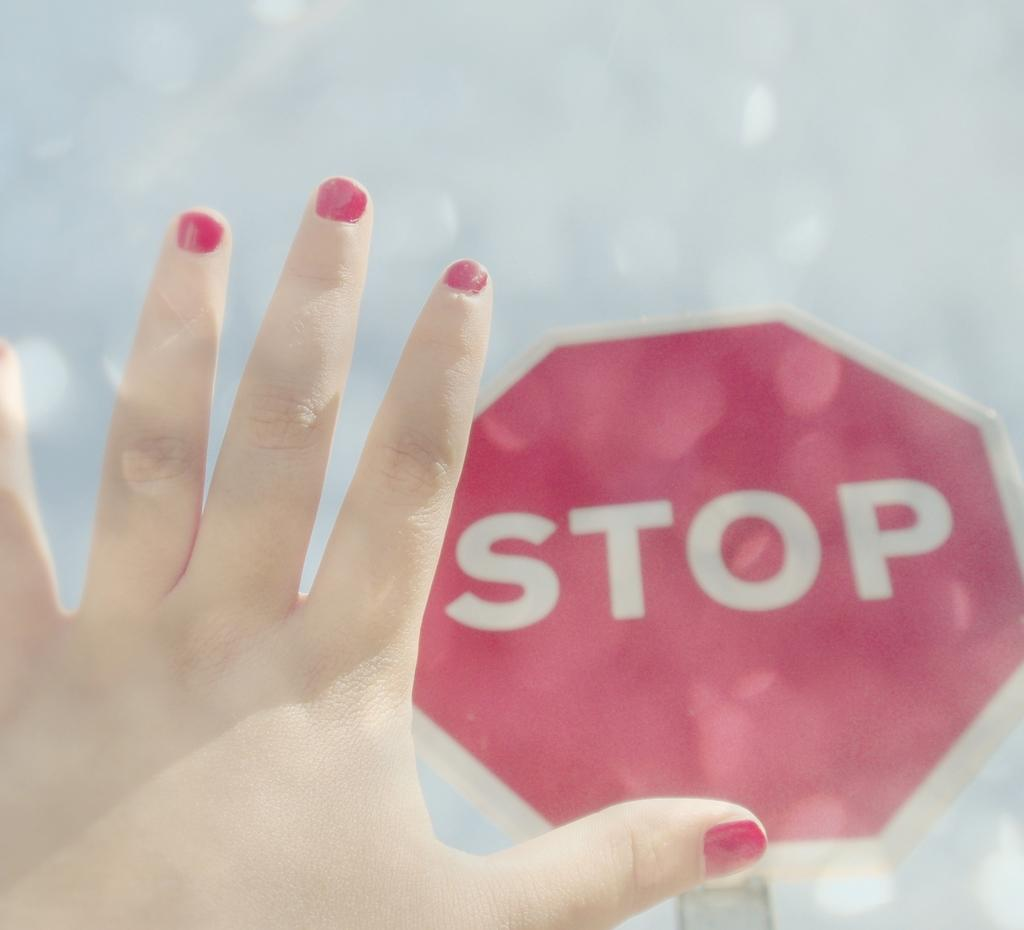What part of a person's body is visible in the image? There is a person's hand in the image. What object is present in the image that might provide information or directions? There is a sign board in the image. What decision is being made by the planes in the image? There are no planes present in the image, so no decision-making involving planes can be observed. What fact is being conveyed by the person's hand in the image? The image does not convey any specific fact through the person's hand; it is simply a hand visible in the image. 